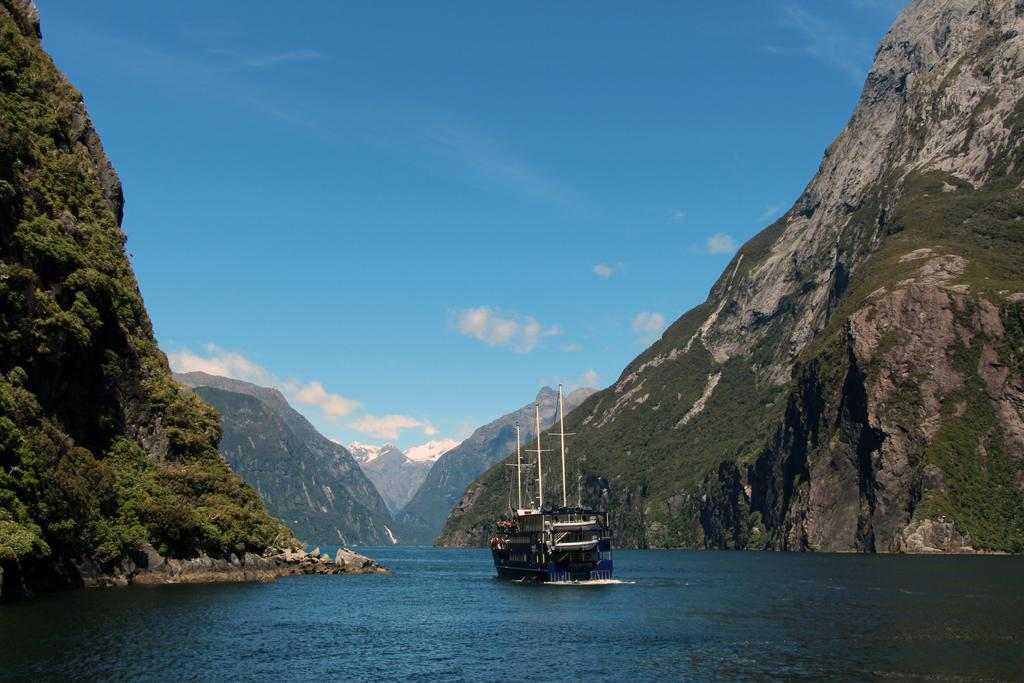What is at the bottom of the image? There is water at the bottom of the image. What is on the water in the image? There is a ship on the water. What type of landscape can be seen in the image? Hills are visible in the image. What is visible at the top of the image? The sky is visible at the top of the image. What can be seen in the sky in the image? There are clouds in the sky. How many dogs are playing in the mine in the image? There are no dogs or mines present in the image. What type of mine is visible in the image? There is no mine present in the image. 